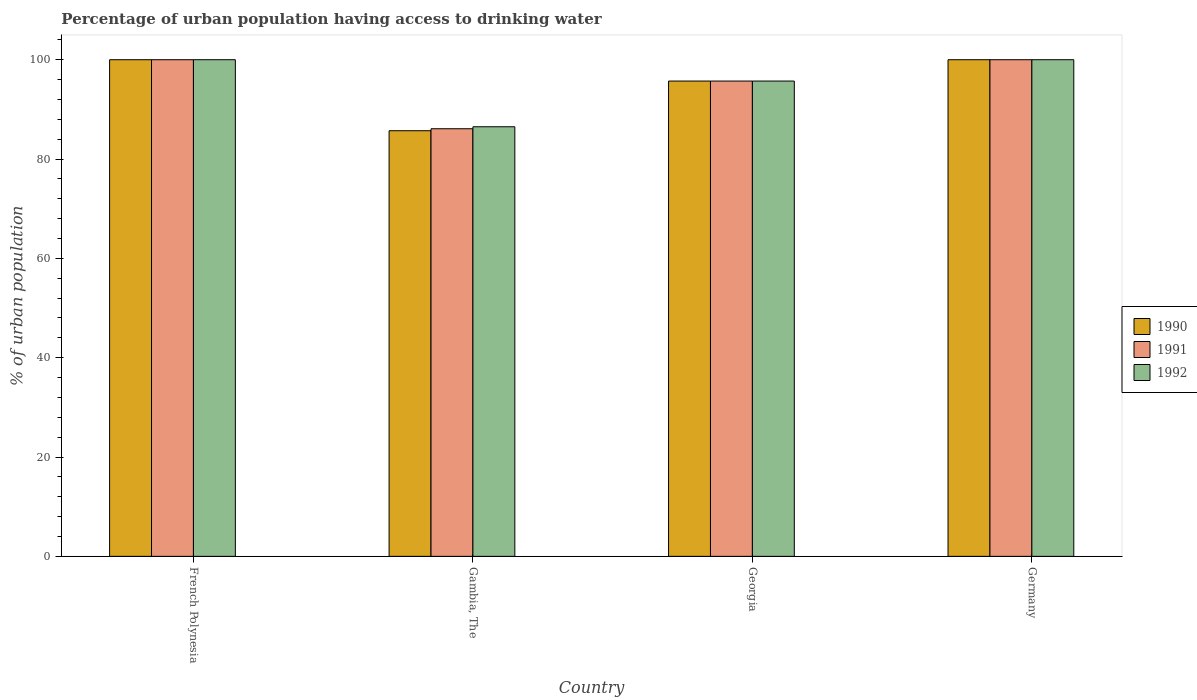How many different coloured bars are there?
Offer a very short reply. 3. How many groups of bars are there?
Your response must be concise. 4. Are the number of bars on each tick of the X-axis equal?
Give a very brief answer. Yes. How many bars are there on the 4th tick from the left?
Offer a very short reply. 3. How many bars are there on the 1st tick from the right?
Provide a short and direct response. 3. What is the percentage of urban population having access to drinking water in 1992 in Georgia?
Offer a terse response. 95.7. Across all countries, what is the minimum percentage of urban population having access to drinking water in 1990?
Make the answer very short. 85.7. In which country was the percentage of urban population having access to drinking water in 1991 maximum?
Provide a short and direct response. French Polynesia. In which country was the percentage of urban population having access to drinking water in 1991 minimum?
Provide a succinct answer. Gambia, The. What is the total percentage of urban population having access to drinking water in 1991 in the graph?
Your answer should be very brief. 381.8. What is the average percentage of urban population having access to drinking water in 1990 per country?
Ensure brevity in your answer.  95.35. What is the difference between the percentage of urban population having access to drinking water of/in 1991 and percentage of urban population having access to drinking water of/in 1992 in Gambia, The?
Provide a short and direct response. -0.4. In how many countries, is the percentage of urban population having access to drinking water in 1992 greater than 72 %?
Your answer should be very brief. 4. What is the ratio of the percentage of urban population having access to drinking water in 1991 in Georgia to that in Germany?
Your answer should be compact. 0.96. Is the percentage of urban population having access to drinking water in 1992 in French Polynesia less than that in Gambia, The?
Offer a very short reply. No. What is the difference between the highest and the second highest percentage of urban population having access to drinking water in 1991?
Make the answer very short. 4.3. What is the difference between the highest and the lowest percentage of urban population having access to drinking water in 1992?
Your response must be concise. 13.5. Is the sum of the percentage of urban population having access to drinking water in 1991 in French Polynesia and Germany greater than the maximum percentage of urban population having access to drinking water in 1992 across all countries?
Your answer should be very brief. Yes. What does the 3rd bar from the left in Georgia represents?
Ensure brevity in your answer.  1992. Is it the case that in every country, the sum of the percentage of urban population having access to drinking water in 1992 and percentage of urban population having access to drinking water in 1991 is greater than the percentage of urban population having access to drinking water in 1990?
Ensure brevity in your answer.  Yes. Are all the bars in the graph horizontal?
Your answer should be very brief. No. What is the difference between two consecutive major ticks on the Y-axis?
Provide a short and direct response. 20. What is the title of the graph?
Provide a short and direct response. Percentage of urban population having access to drinking water. What is the label or title of the X-axis?
Your answer should be compact. Country. What is the label or title of the Y-axis?
Provide a short and direct response. % of urban population. What is the % of urban population of 1991 in French Polynesia?
Your response must be concise. 100. What is the % of urban population of 1992 in French Polynesia?
Make the answer very short. 100. What is the % of urban population in 1990 in Gambia, The?
Provide a succinct answer. 85.7. What is the % of urban population in 1991 in Gambia, The?
Your answer should be compact. 86.1. What is the % of urban population in 1992 in Gambia, The?
Provide a short and direct response. 86.5. What is the % of urban population in 1990 in Georgia?
Provide a short and direct response. 95.7. What is the % of urban population of 1991 in Georgia?
Keep it short and to the point. 95.7. What is the % of urban population in 1992 in Georgia?
Ensure brevity in your answer.  95.7. Across all countries, what is the maximum % of urban population of 1991?
Ensure brevity in your answer.  100. Across all countries, what is the maximum % of urban population in 1992?
Provide a short and direct response. 100. Across all countries, what is the minimum % of urban population in 1990?
Keep it short and to the point. 85.7. Across all countries, what is the minimum % of urban population of 1991?
Keep it short and to the point. 86.1. Across all countries, what is the minimum % of urban population in 1992?
Offer a terse response. 86.5. What is the total % of urban population of 1990 in the graph?
Keep it short and to the point. 381.4. What is the total % of urban population of 1991 in the graph?
Your answer should be very brief. 381.8. What is the total % of urban population of 1992 in the graph?
Your answer should be compact. 382.2. What is the difference between the % of urban population in 1991 in French Polynesia and that in Gambia, The?
Offer a very short reply. 13.9. What is the difference between the % of urban population of 1992 in French Polynesia and that in Georgia?
Your answer should be compact. 4.3. What is the difference between the % of urban population of 1990 in French Polynesia and that in Germany?
Provide a short and direct response. 0. What is the difference between the % of urban population in 1991 in French Polynesia and that in Germany?
Keep it short and to the point. 0. What is the difference between the % of urban population of 1992 in French Polynesia and that in Germany?
Ensure brevity in your answer.  0. What is the difference between the % of urban population in 1990 in Gambia, The and that in Georgia?
Offer a terse response. -10. What is the difference between the % of urban population of 1992 in Gambia, The and that in Georgia?
Make the answer very short. -9.2. What is the difference between the % of urban population in 1990 in Gambia, The and that in Germany?
Provide a short and direct response. -14.3. What is the difference between the % of urban population of 1991 in Gambia, The and that in Germany?
Provide a succinct answer. -13.9. What is the difference between the % of urban population of 1992 in Gambia, The and that in Germany?
Provide a succinct answer. -13.5. What is the difference between the % of urban population of 1991 in Georgia and that in Germany?
Your answer should be compact. -4.3. What is the difference between the % of urban population in 1991 in French Polynesia and the % of urban population in 1992 in Gambia, The?
Provide a succinct answer. 13.5. What is the difference between the % of urban population of 1990 in French Polynesia and the % of urban population of 1992 in Georgia?
Your response must be concise. 4.3. What is the difference between the % of urban population of 1990 in French Polynesia and the % of urban population of 1992 in Germany?
Keep it short and to the point. 0. What is the difference between the % of urban population in 1991 in Gambia, The and the % of urban population in 1992 in Georgia?
Ensure brevity in your answer.  -9.6. What is the difference between the % of urban population of 1990 in Gambia, The and the % of urban population of 1991 in Germany?
Provide a succinct answer. -14.3. What is the difference between the % of urban population of 1990 in Gambia, The and the % of urban population of 1992 in Germany?
Provide a short and direct response. -14.3. What is the difference between the % of urban population in 1991 in Gambia, The and the % of urban population in 1992 in Germany?
Offer a very short reply. -13.9. What is the difference between the % of urban population in 1990 in Georgia and the % of urban population in 1992 in Germany?
Your answer should be compact. -4.3. What is the average % of urban population in 1990 per country?
Give a very brief answer. 95.35. What is the average % of urban population in 1991 per country?
Keep it short and to the point. 95.45. What is the average % of urban population of 1992 per country?
Provide a succinct answer. 95.55. What is the difference between the % of urban population of 1990 and % of urban population of 1992 in Gambia, The?
Offer a very short reply. -0.8. What is the difference between the % of urban population in 1990 and % of urban population in 1991 in Georgia?
Offer a terse response. 0. What is the difference between the % of urban population of 1990 and % of urban population of 1992 in Georgia?
Your answer should be very brief. 0. What is the difference between the % of urban population in 1990 and % of urban population in 1992 in Germany?
Provide a succinct answer. 0. What is the difference between the % of urban population of 1991 and % of urban population of 1992 in Germany?
Your response must be concise. 0. What is the ratio of the % of urban population of 1990 in French Polynesia to that in Gambia, The?
Make the answer very short. 1.17. What is the ratio of the % of urban population in 1991 in French Polynesia to that in Gambia, The?
Make the answer very short. 1.16. What is the ratio of the % of urban population in 1992 in French Polynesia to that in Gambia, The?
Offer a terse response. 1.16. What is the ratio of the % of urban population in 1990 in French Polynesia to that in Georgia?
Offer a terse response. 1.04. What is the ratio of the % of urban population of 1991 in French Polynesia to that in Georgia?
Give a very brief answer. 1.04. What is the ratio of the % of urban population of 1992 in French Polynesia to that in Georgia?
Your response must be concise. 1.04. What is the ratio of the % of urban population in 1990 in Gambia, The to that in Georgia?
Ensure brevity in your answer.  0.9. What is the ratio of the % of urban population of 1991 in Gambia, The to that in Georgia?
Make the answer very short. 0.9. What is the ratio of the % of urban population of 1992 in Gambia, The to that in Georgia?
Provide a short and direct response. 0.9. What is the ratio of the % of urban population in 1990 in Gambia, The to that in Germany?
Offer a terse response. 0.86. What is the ratio of the % of urban population of 1991 in Gambia, The to that in Germany?
Your answer should be very brief. 0.86. What is the ratio of the % of urban population in 1992 in Gambia, The to that in Germany?
Make the answer very short. 0.86. What is the ratio of the % of urban population in 1990 in Georgia to that in Germany?
Provide a short and direct response. 0.96. What is the ratio of the % of urban population in 1991 in Georgia to that in Germany?
Your answer should be very brief. 0.96. What is the difference between the highest and the second highest % of urban population in 1990?
Your answer should be very brief. 0. What is the difference between the highest and the second highest % of urban population in 1991?
Your answer should be very brief. 0. What is the difference between the highest and the lowest % of urban population in 1991?
Your response must be concise. 13.9. 